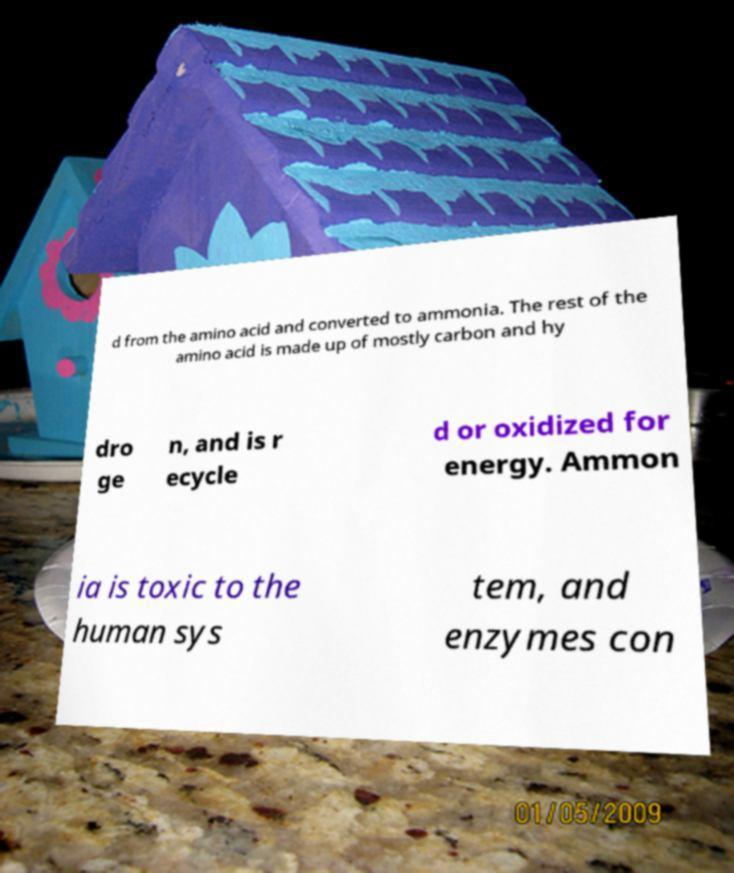Can you read and provide the text displayed in the image?This photo seems to have some interesting text. Can you extract and type it out for me? d from the amino acid and converted to ammonia. The rest of the amino acid is made up of mostly carbon and hy dro ge n, and is r ecycle d or oxidized for energy. Ammon ia is toxic to the human sys tem, and enzymes con 